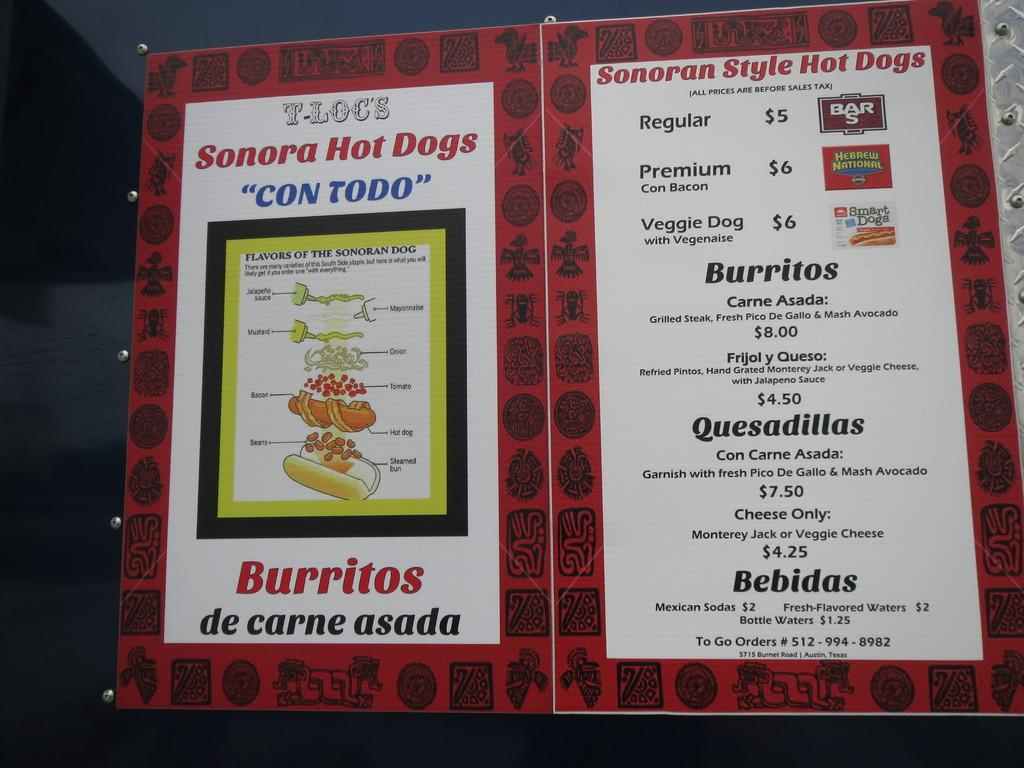<image>
Give a short and clear explanation of the subsequent image. menu for t-loc's sonora hot dogs they also have burritos, quesadillas, and bebidas 